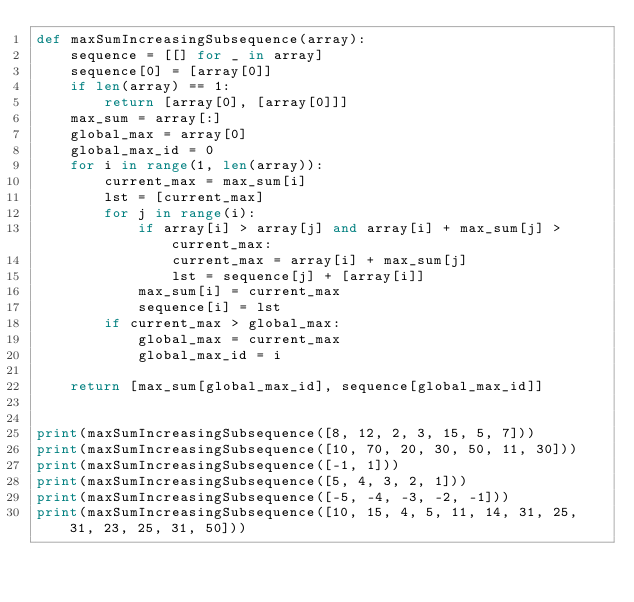Convert code to text. <code><loc_0><loc_0><loc_500><loc_500><_Python_>def maxSumIncreasingSubsequence(array):
    sequence = [[] for _ in array]
    sequence[0] = [array[0]]
    if len(array) == 1:
        return [array[0], [array[0]]]
    max_sum = array[:]
    global_max = array[0]
    global_max_id = 0
    for i in range(1, len(array)):
        current_max = max_sum[i]
        lst = [current_max]
        for j in range(i):
            if array[i] > array[j] and array[i] + max_sum[j] > current_max:
                current_max = array[i] + max_sum[j]
                lst = sequence[j] + [array[i]]
            max_sum[i] = current_max
            sequence[i] = lst
        if current_max > global_max:
            global_max = current_max
            global_max_id = i

    return [max_sum[global_max_id], sequence[global_max_id]]


print(maxSumIncreasingSubsequence([8, 12, 2, 3, 15, 5, 7]))
print(maxSumIncreasingSubsequence([10, 70, 20, 30, 50, 11, 30]))
print(maxSumIncreasingSubsequence([-1, 1]))
print(maxSumIncreasingSubsequence([5, 4, 3, 2, 1]))
print(maxSumIncreasingSubsequence([-5, -4, -3, -2, -1]))
print(maxSumIncreasingSubsequence([10, 15, 4, 5, 11, 14, 31, 25, 31, 23, 25, 31, 50]))
</code> 